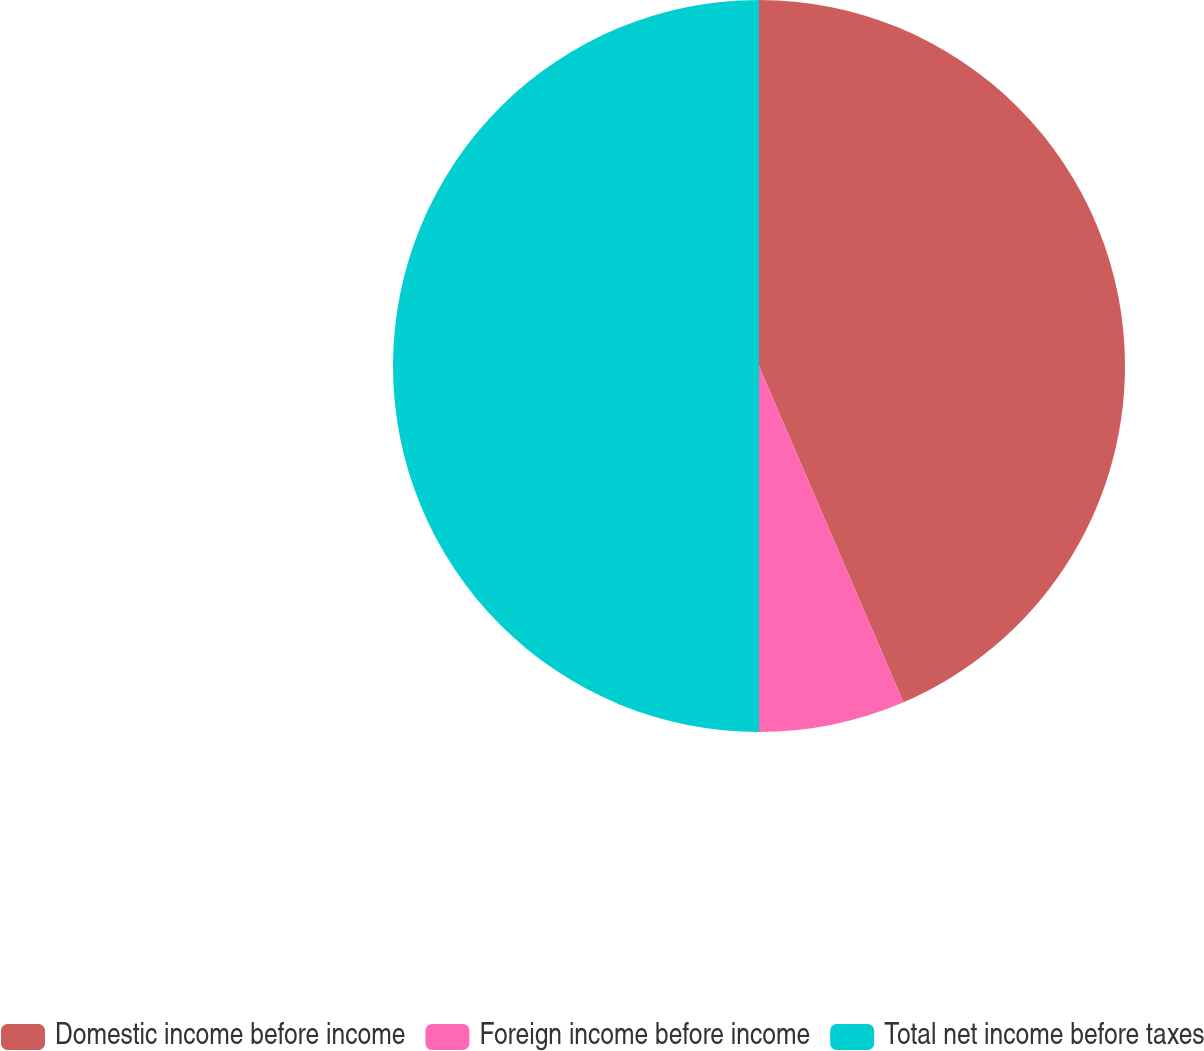Convert chart. <chart><loc_0><loc_0><loc_500><loc_500><pie_chart><fcel>Domestic income before income<fcel>Foreign income before income<fcel>Total net income before taxes<nl><fcel>43.54%<fcel>6.46%<fcel>50.0%<nl></chart> 